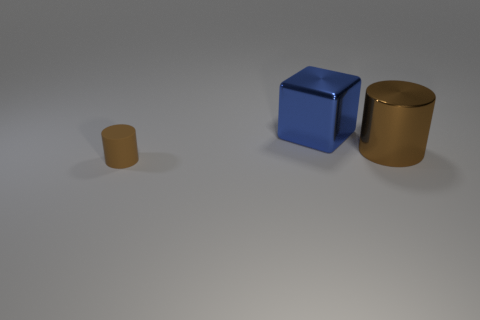Add 1 blue shiny things. How many objects exist? 4 Subtract 1 blocks. How many blocks are left? 0 Subtract all blocks. How many objects are left? 2 Subtract 1 brown cylinders. How many objects are left? 2 Subtract all gray blocks. Subtract all yellow balls. How many blocks are left? 1 Subtract all blue cubes. How many green cylinders are left? 0 Subtract all large brown cylinders. Subtract all small yellow metallic cubes. How many objects are left? 2 Add 1 blocks. How many blocks are left? 2 Add 3 cyan matte blocks. How many cyan matte blocks exist? 3 